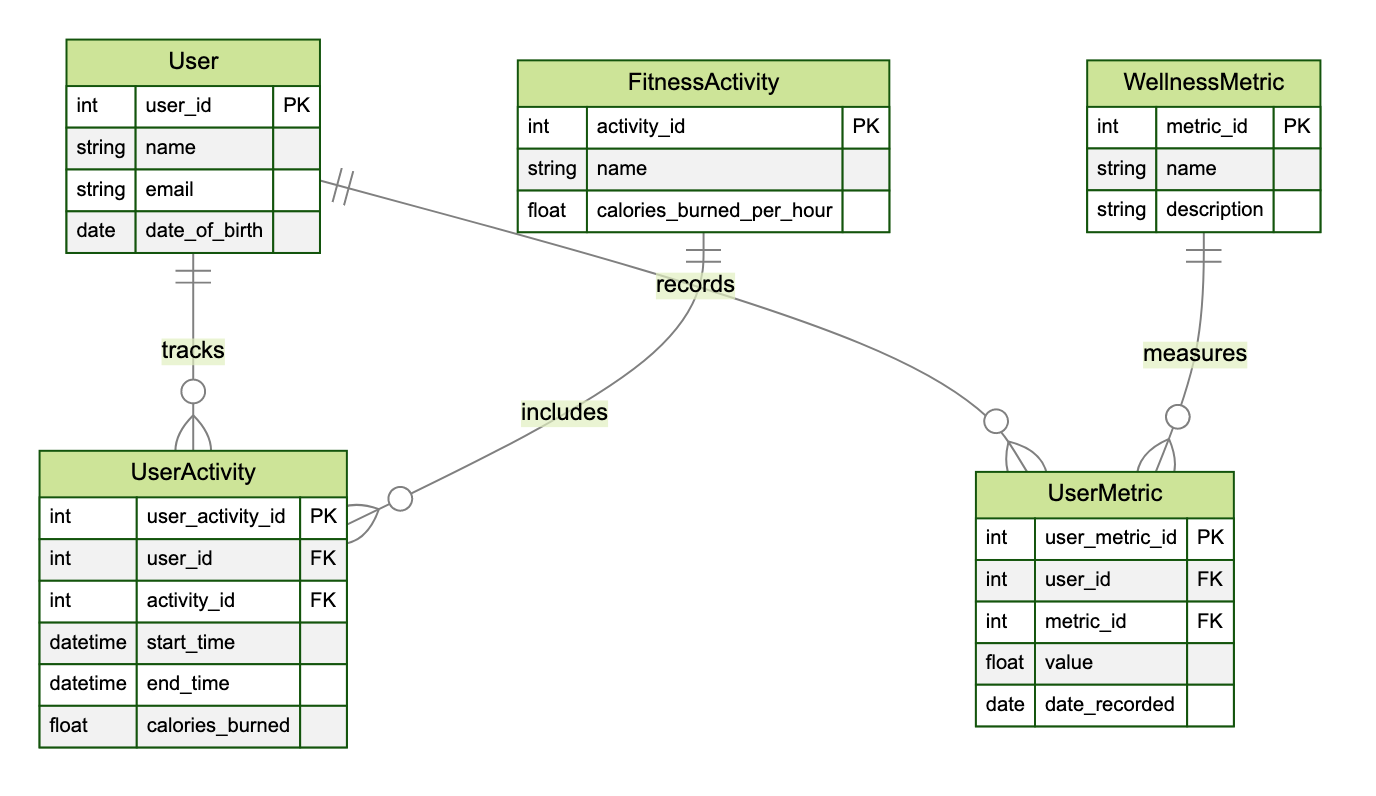What is the primary key of the User entity? The primary key for the User entity is specified in the diagram as "user_id". This attribute uniquely identifies each user in the database, making it the primary key.
Answer: user_id How many attributes does the FitnessActivity entity have? The FitnessActivity entity includes three attributes: activity_id, name, and calories_burned_per_hour. By counting these attributes, we arrive at the total.
Answer: 3 What does the UserActivity entity track? The UserActivity entity captures information about various fitness activities performed by users, which includes details such as the user identifier, activity identifier, start and end times, and calories burned. This is inferred directly from the attributes in the entity.
Answer: fitness activities Which entity measures wellness metrics? The UserMetric entity operates under the WellnessMetric entity to provide detailed records of wellness measuring metrics, as indicated by the relationships described.
Answer: UserMetric What is the relationship type between User and UserActivity? In the diagram, the relationship between User and UserActivity is defined as "OneToMany". This means that each user can be associated with multiple user activity records.
Answer: OneToMany What is the foreign key in UserActivity referencing the User entity? The foreign key in the UserActivity entity referencing the User entity is "user_id". This key establishes the link between a user and their associated activities as laid out in the diagram.
Answer: user_id How many relationships are there in total? By reviewing the relationships section of the diagram, there are four distinct relationships outlined, indicating how entities are linked together in the context of fitness and wellness tracking.
Answer: 4 Which entity is associated with measuring calories burned? The UserActivity entity includes the attribute for calories burned, thus linking it directly to fitness activities and the measurement of calories burned by the user during those activities.
Answer: UserActivity What type of relationship exists between WellnessMetric and UserMetric? In the diagram, the relationship established between WellnessMetric and UserMetric is defined as "OneToMany", indicating that one wellness metric can be recorded multiple times for different instances of user metrics.
Answer: OneToMany 